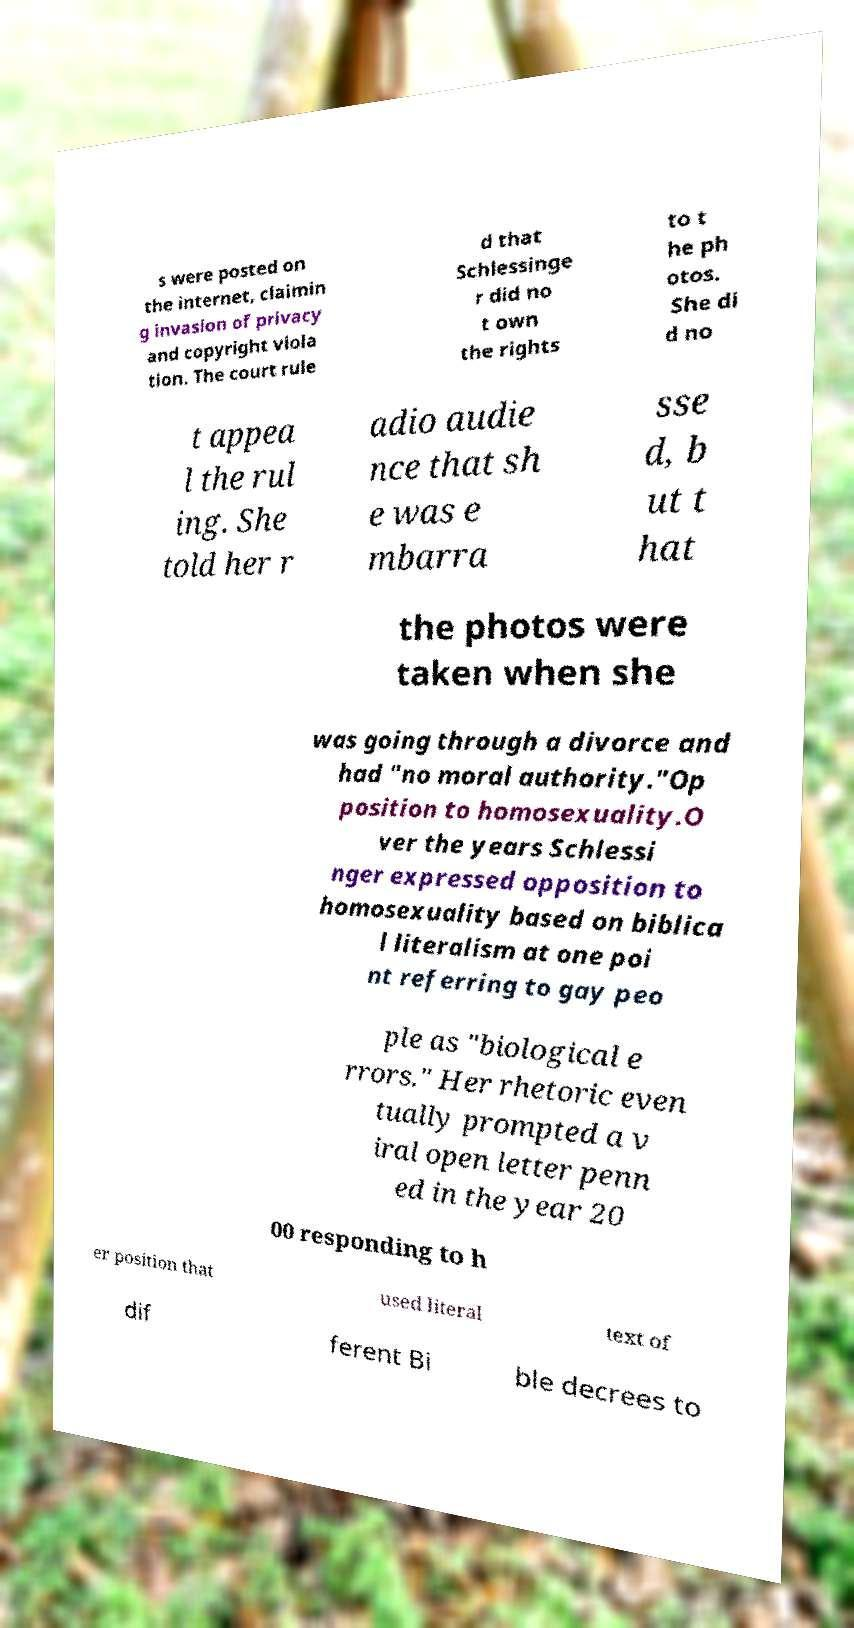I need the written content from this picture converted into text. Can you do that? s were posted on the internet, claimin g invasion of privacy and copyright viola tion. The court rule d that Schlessinge r did no t own the rights to t he ph otos. She di d no t appea l the rul ing. She told her r adio audie nce that sh e was e mbarra sse d, b ut t hat the photos were taken when she was going through a divorce and had "no moral authority."Op position to homosexuality.O ver the years Schlessi nger expressed opposition to homosexuality based on biblica l literalism at one poi nt referring to gay peo ple as "biological e rrors." Her rhetoric even tually prompted a v iral open letter penn ed in the year 20 00 responding to h er position that used literal text of dif ferent Bi ble decrees to 